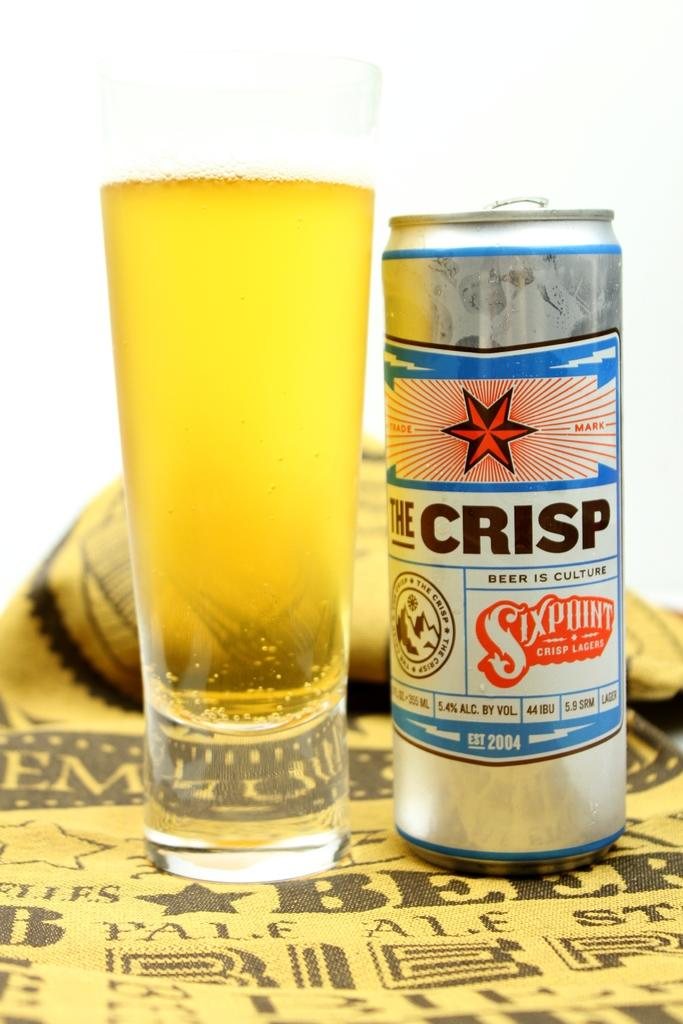Provide a one-sentence caption for the provided image. A full glass and a can of The Crisp beer. 